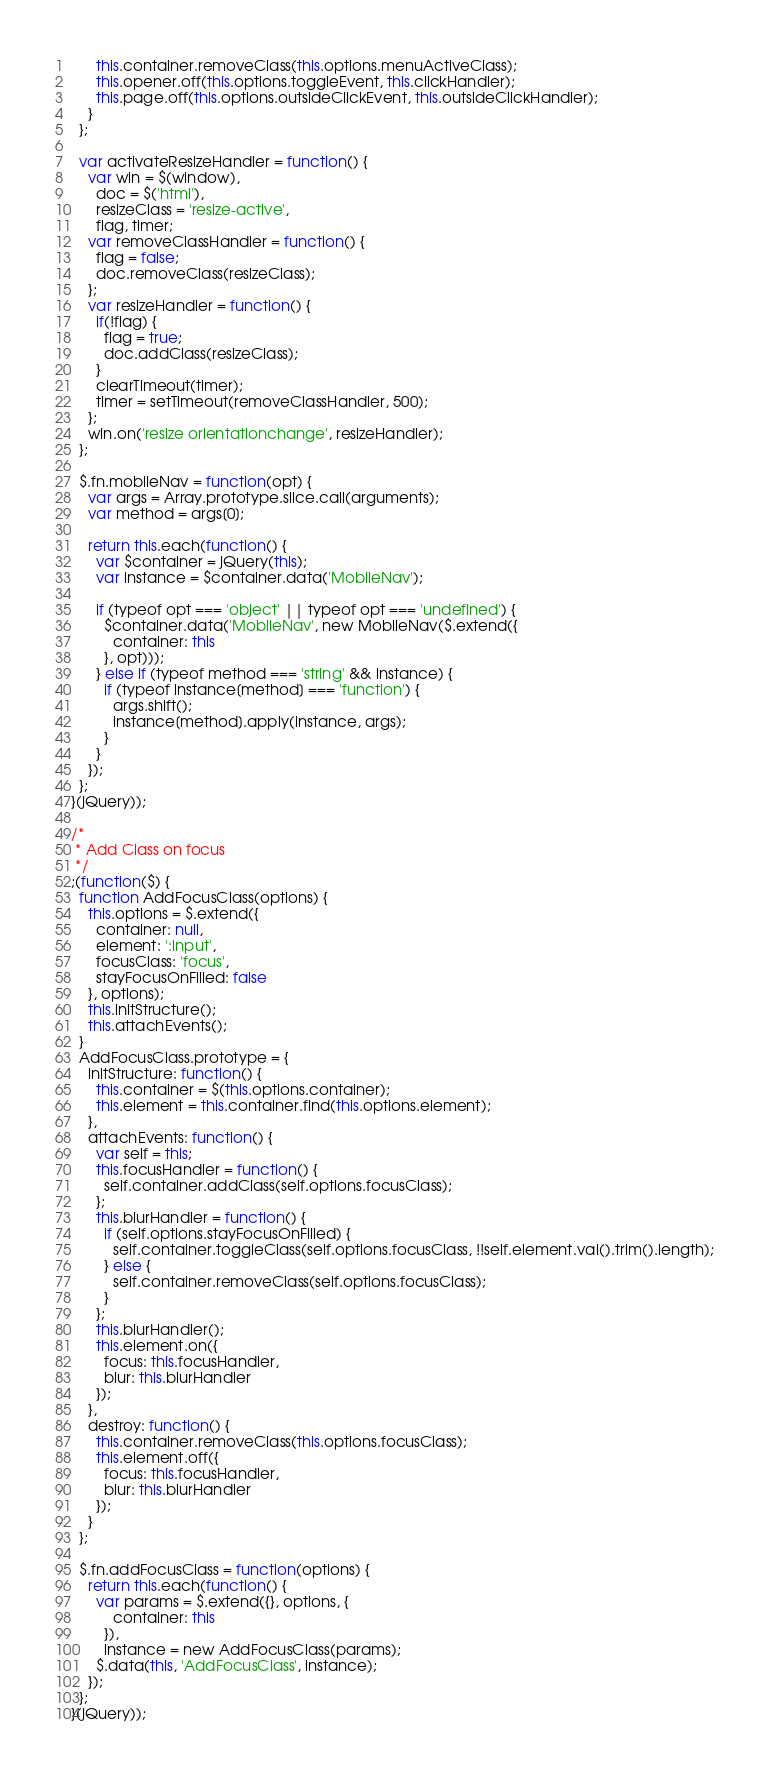<code> <loc_0><loc_0><loc_500><loc_500><_JavaScript_>      this.container.removeClass(this.options.menuActiveClass);
      this.opener.off(this.options.toggleEvent, this.clickHandler);
      this.page.off(this.options.outsideClickEvent, this.outsideClickHandler);
    }
  };

  var activateResizeHandler = function() {
    var win = $(window),
      doc = $('html'),
      resizeClass = 'resize-active',
      flag, timer;
    var removeClassHandler = function() {
      flag = false;
      doc.removeClass(resizeClass);
    };
    var resizeHandler = function() {
      if(!flag) {
        flag = true;
        doc.addClass(resizeClass);
      }
      clearTimeout(timer);
      timer = setTimeout(removeClassHandler, 500);
    };
    win.on('resize orientationchange', resizeHandler);
  };

  $.fn.mobileNav = function(opt) {
    var args = Array.prototype.slice.call(arguments);
    var method = args[0];

    return this.each(function() {
      var $container = jQuery(this);
      var instance = $container.data('MobileNav');

      if (typeof opt === 'object' || typeof opt === 'undefined') {
        $container.data('MobileNav', new MobileNav($.extend({
          container: this
        }, opt)));
      } else if (typeof method === 'string' && instance) {
        if (typeof instance[method] === 'function') {
          args.shift();
          instance[method].apply(instance, args);
        }
      }
    });
  };
}(jQuery));

/*
 * Add Class on focus
 */
;(function($) {
  function AddFocusClass(options) {
    this.options = $.extend({
      container: null,
      element: ':input',
      focusClass: 'focus',
      stayFocusOnFilled: false
    }, options);
    this.initStructure();
    this.attachEvents();
  }
  AddFocusClass.prototype = {
    initStructure: function() {
      this.container = $(this.options.container);
      this.element = this.container.find(this.options.element);
    },
    attachEvents: function() {
      var self = this;
      this.focusHandler = function() {
        self.container.addClass(self.options.focusClass);
      };
      this.blurHandler = function() {
        if (self.options.stayFocusOnFilled) {
          self.container.toggleClass(self.options.focusClass, !!self.element.val().trim().length);
        } else {
          self.container.removeClass(self.options.focusClass);
        }
      };
      this.blurHandler();
      this.element.on({
        focus: this.focusHandler,
        blur: this.blurHandler
      });
    },
    destroy: function() {
      this.container.removeClass(this.options.focusClass);
      this.element.off({
        focus: this.focusHandler,
        blur: this.blurHandler
      });
    }
  };

  $.fn.addFocusClass = function(options) {
    return this.each(function() {
      var params = $.extend({}, options, {
          container: this
        }),
        instance = new AddFocusClass(params);
      $.data(this, 'AddFocusClass', instance);
    });
  };
}(jQuery));

</code> 